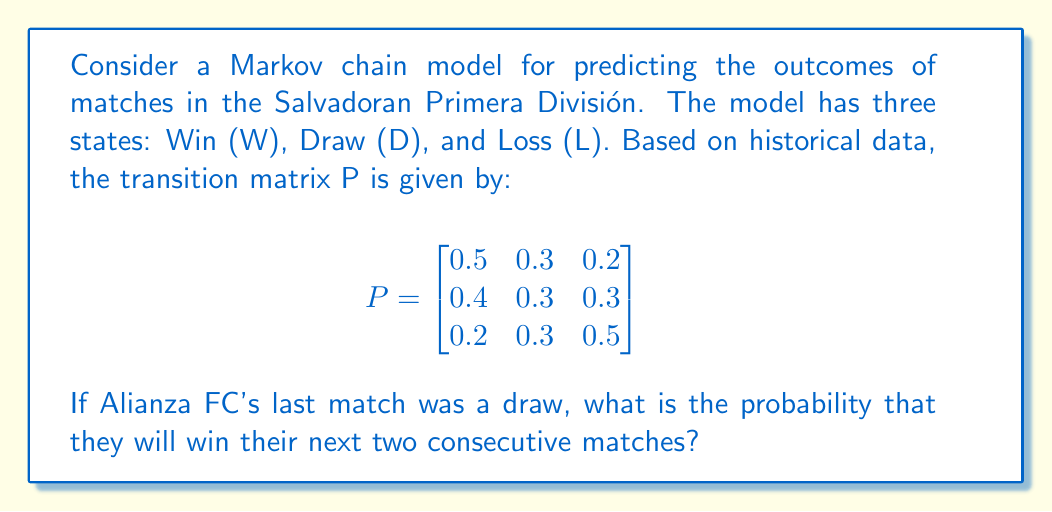Show me your answer to this math problem. To solve this problem, we'll follow these steps:

1. Identify the initial state: Since Alianza FC's last match was a draw, our initial state is D.

2. Calculate the probability of winning the next match:
   From the transition matrix, P(W|D) = 0.4

3. Calculate the probability of winning the second match, given that they won the first:
   From the transition matrix, P(W|W) = 0.5

4. Apply the multiplication rule of probability:
   The probability of both events occurring is the product of their individual probabilities.

   P(Win next two matches | Last match was a draw) = P(W|D) × P(W|W)
   
   $= 0.4 \times 0.5 = 0.2$

Therefore, the probability of Alianza FC winning their next two consecutive matches, given that their last match was a draw, is 0.2 or 20%.
Answer: 0.2 